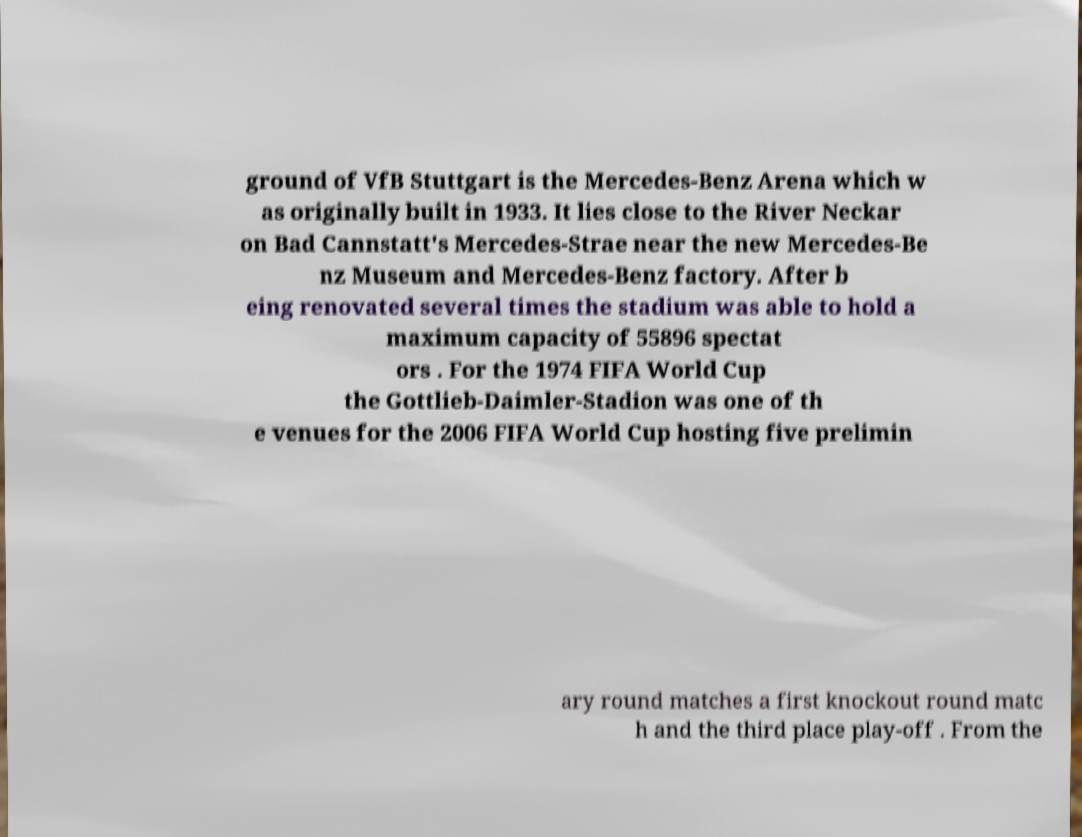Please identify and transcribe the text found in this image. ground of VfB Stuttgart is the Mercedes-Benz Arena which w as originally built in 1933. It lies close to the River Neckar on Bad Cannstatt's Mercedes-Strae near the new Mercedes-Be nz Museum and Mercedes-Benz factory. After b eing renovated several times the stadium was able to hold a maximum capacity of 55896 spectat ors . For the 1974 FIFA World Cup the Gottlieb-Daimler-Stadion was one of th e venues for the 2006 FIFA World Cup hosting five prelimin ary round matches a first knockout round matc h and the third place play-off . From the 